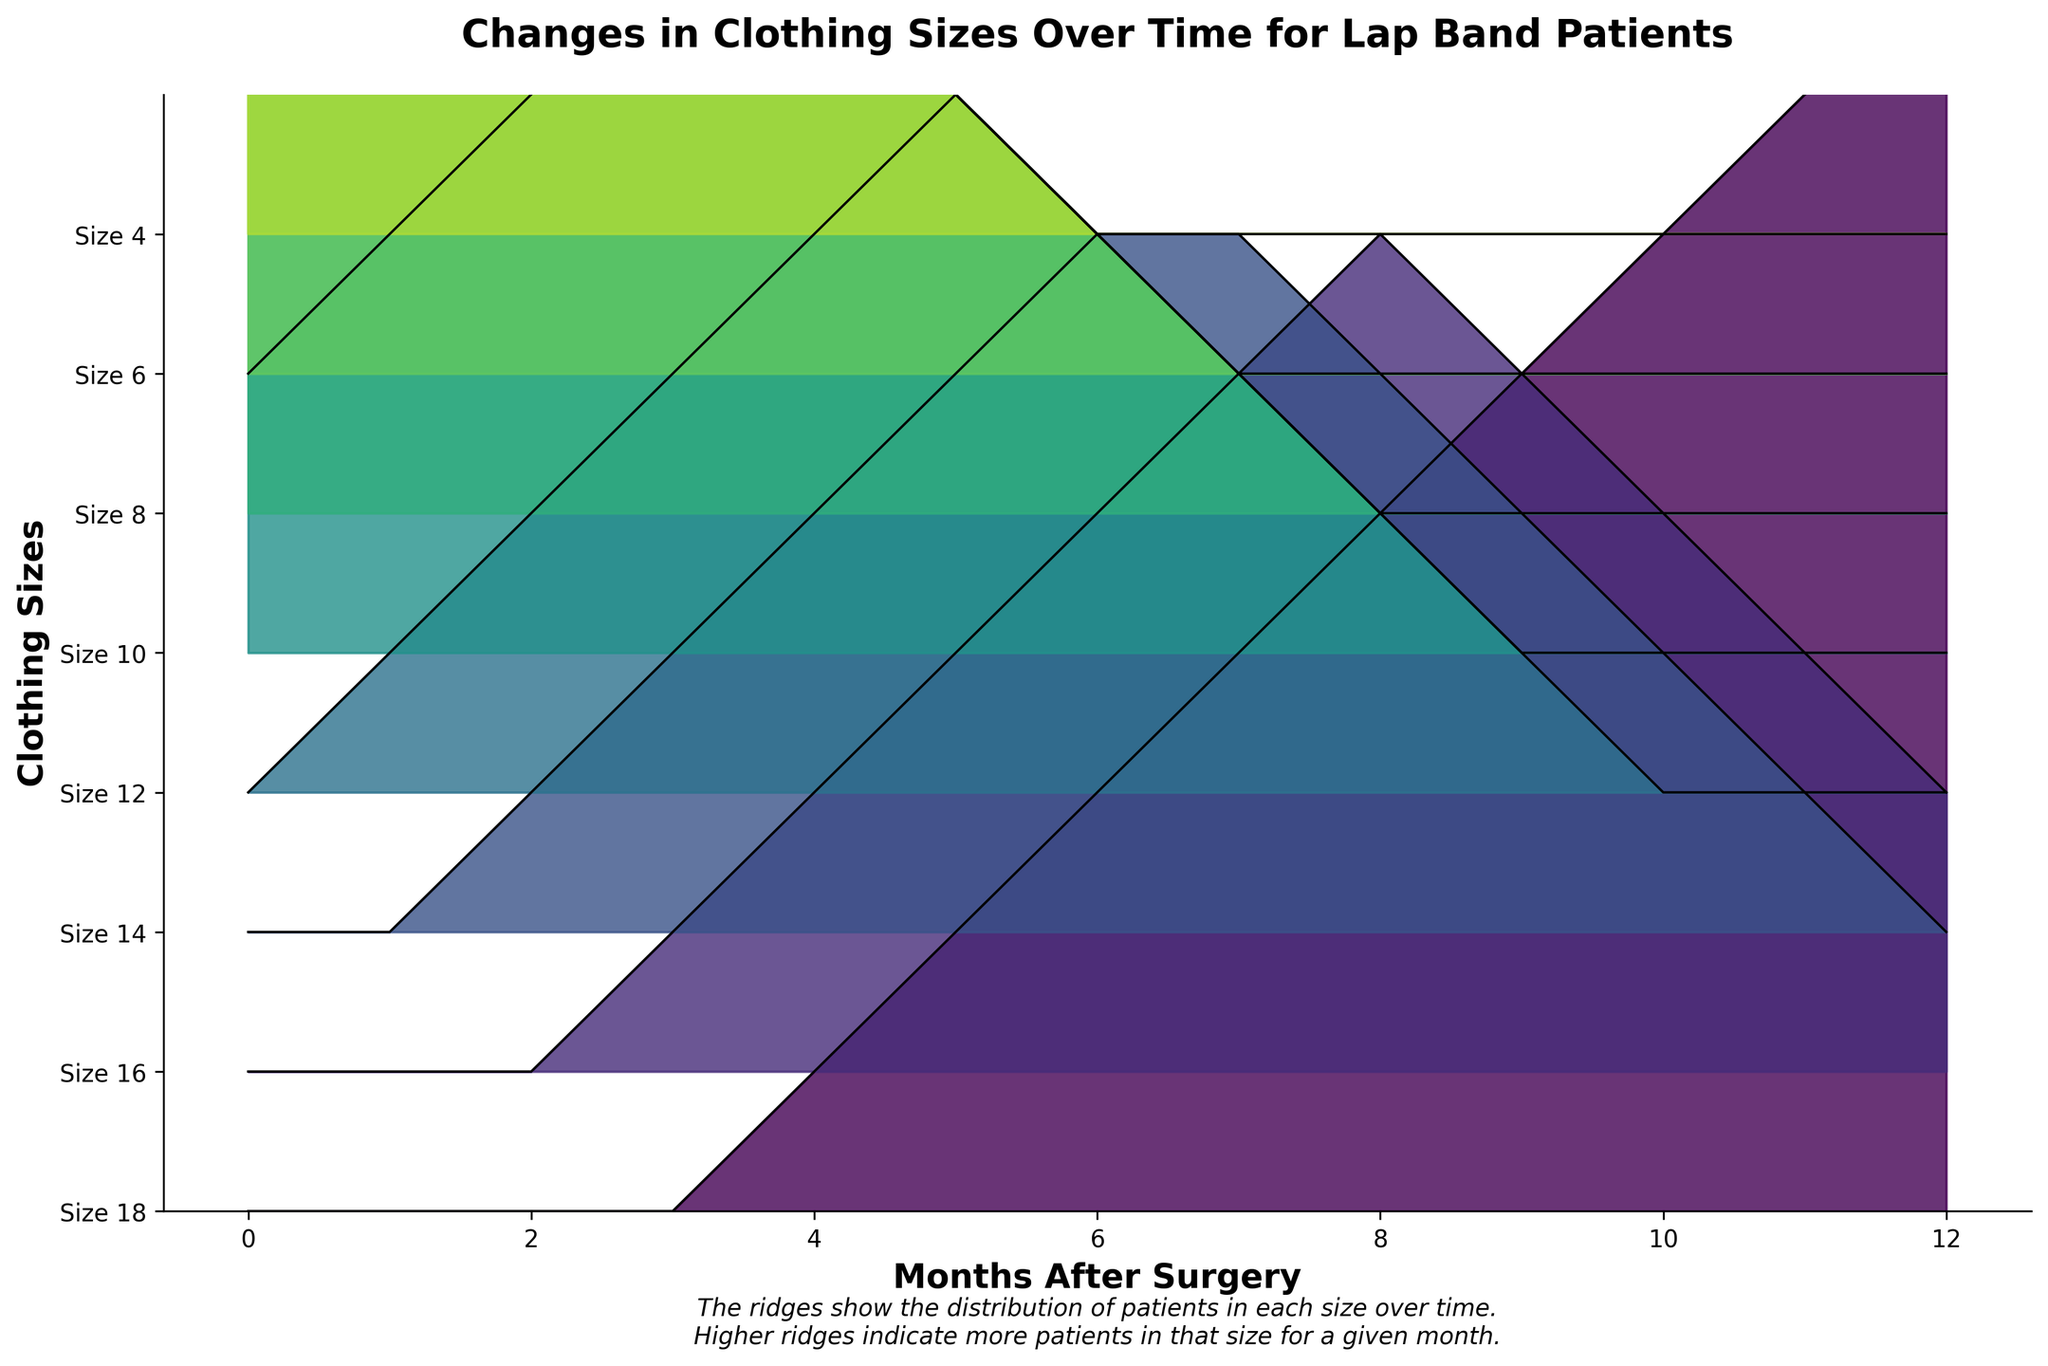What is the title of the figure? The title is usually located at the top of the chart and gives a succinct summary of the data presented. In this case, it specifies the subject and context of the data analysis.
Answer: Changes in Clothing Sizes Over Time for Lap Band Patients How many months of data are shown in the figure? Check the x-axis, which represents the time in months since the surgery, to determine the total number of months presented.
Answer: 13 Which clothing size has the highest number of patients at the beginning (Month 0)? Examine the height of the ridges at Month 0 to determine which clothing size had the highest number of patients. The tallest ridge indicates the most patients.
Answer: Size 18 How does the number of patients wearing Size 6 change from month 0 to month 12? Compare the heights of the Size 6 ridgeline at Month 0 and Month 12 to see how the number of patients fluctuates over this period.
Answer: Increases Which clothing size sees the most significant reduction in the number of patients over the 12 months? Identify the size that has the most considerable drop in ridge height from Month 0 to Month 12. The size starting with a high ridge and ending with a low one indicates a significant reduction.
Answer: Size 18 At which month do more patients start wearing Size 8 compared to Size 10? Compare the ridgelines of Size 8 and Size 10 over the months to find the point where Size 8's ridge exceeds Size 10's ridge.
Answer: Month 2 What is the clothing size distribution trend after 12 months? Observe the heights of the ridges at Month 12 to see the distribution trend. Higher ridges indicate more patients.
Answer: Most patients are in Size 4 How do the ridges indicate the distribution of patients over time? Each ridge's height at any given month shows the number of patients wearing that size. Higher ridges mean more patients. Note how the ridgelines change over time, which sizes grow or shrink.
Answer: Ridges' heights show patient distribution per size over time Based on the figure, at which month do patients shift noticeably toward smaller sizes (Size 4-10)? Look for a month where ridges for smaller sizes start to increase significantly compared to month 0.
Answer: Month 6 Which clothing size shows the first noticeable increase in number of patients? Check the ridgelines for when each size starts to increase from Month 0. The first size to show noticeable growth indicates the shift.
Answer: Size 10 